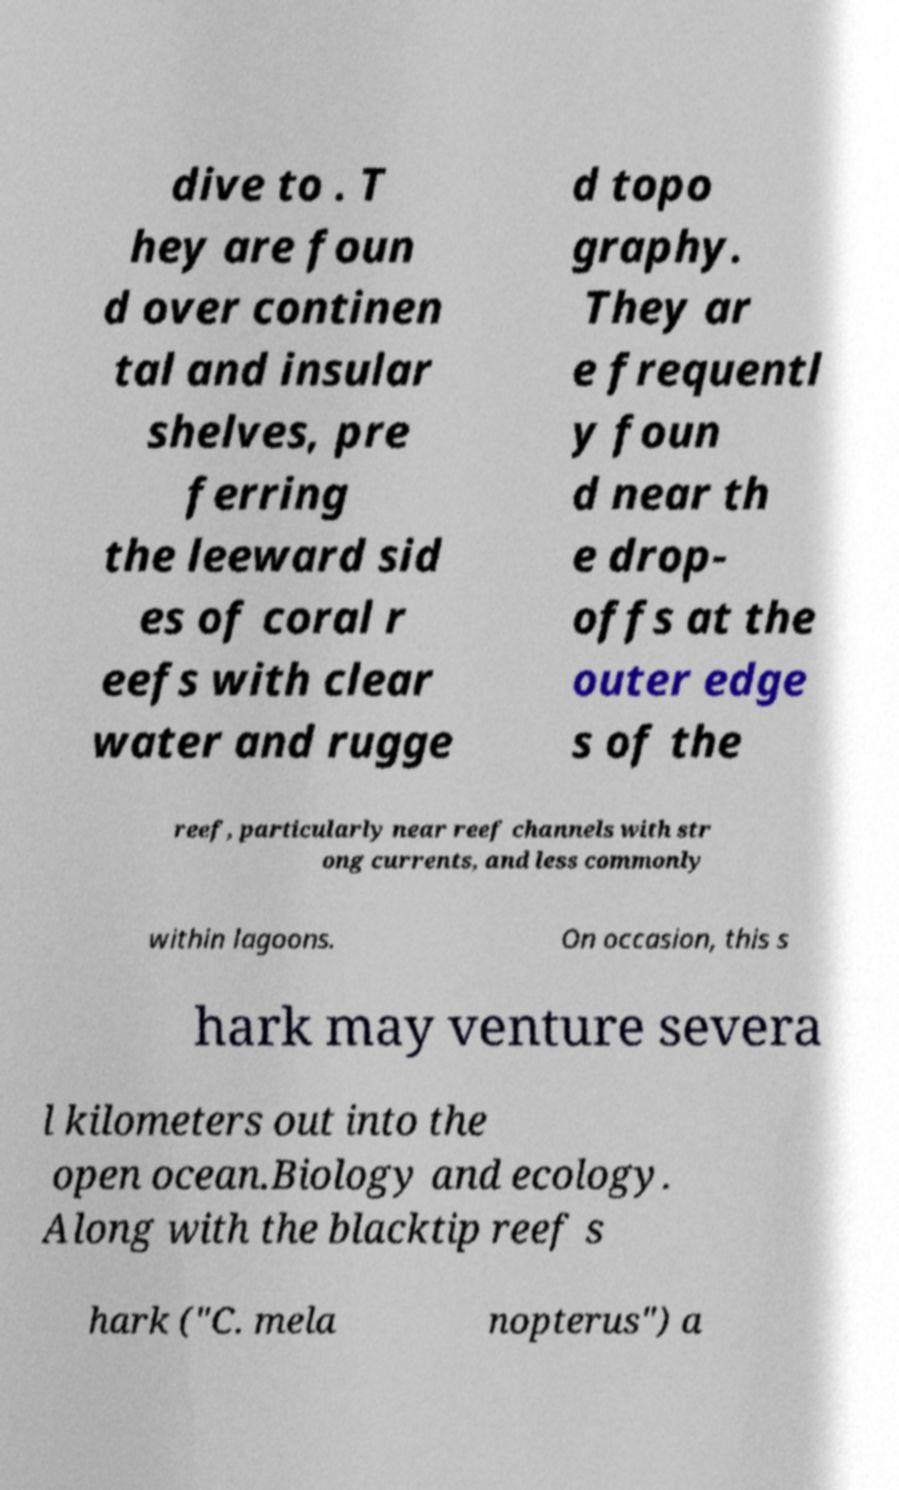Can you read and provide the text displayed in the image?This photo seems to have some interesting text. Can you extract and type it out for me? dive to . T hey are foun d over continen tal and insular shelves, pre ferring the leeward sid es of coral r eefs with clear water and rugge d topo graphy. They ar e frequentl y foun d near th e drop- offs at the outer edge s of the reef, particularly near reef channels with str ong currents, and less commonly within lagoons. On occasion, this s hark may venture severa l kilometers out into the open ocean.Biology and ecology. Along with the blacktip reef s hark ("C. mela nopterus") a 